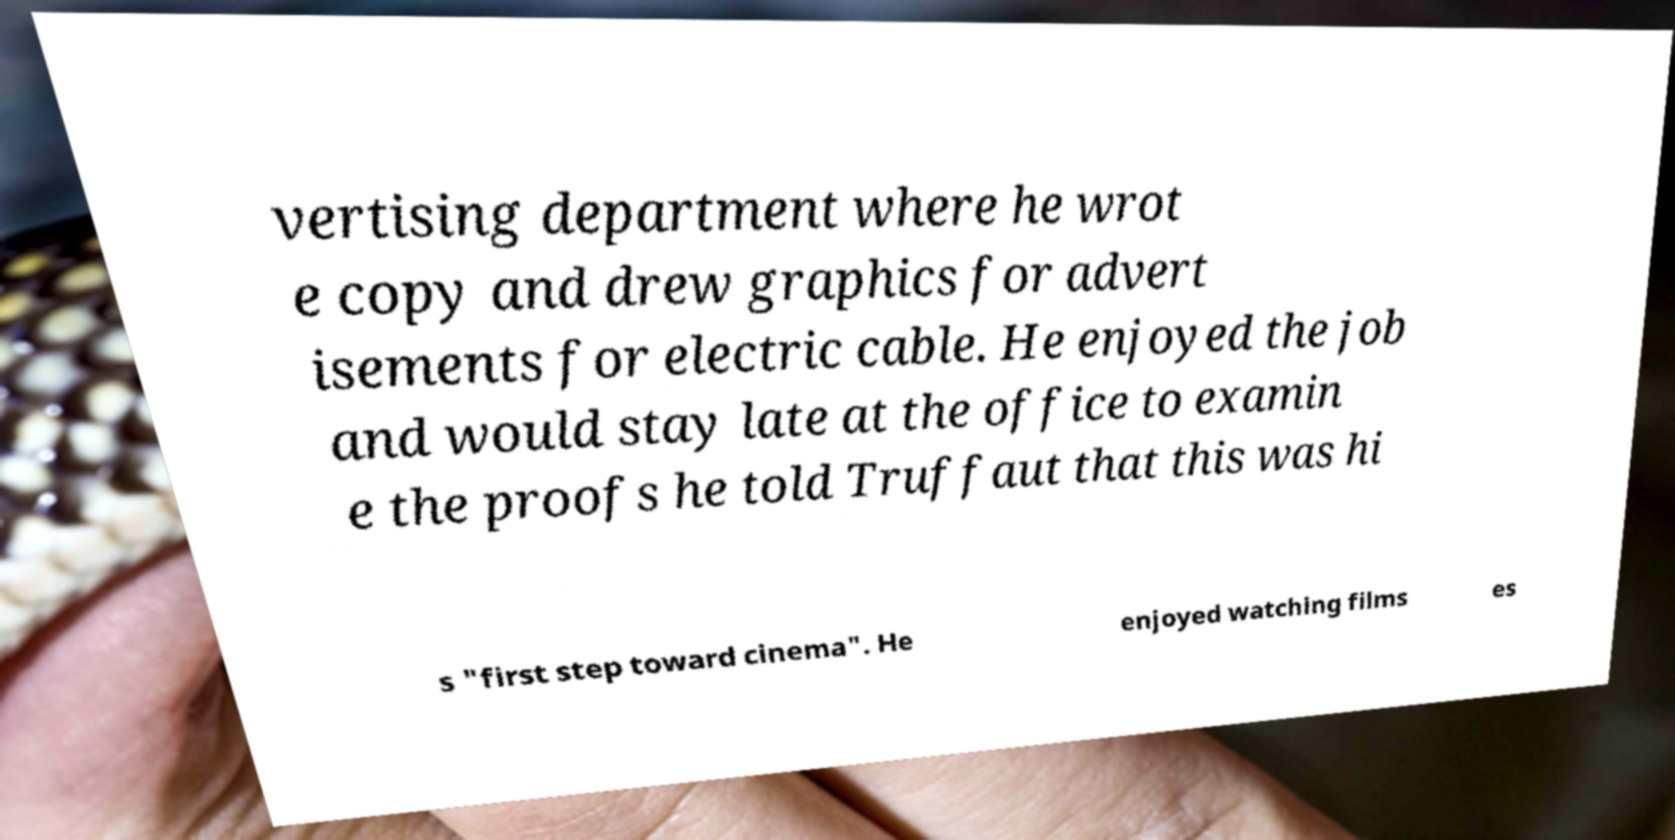Can you accurately transcribe the text from the provided image for me? vertising department where he wrot e copy and drew graphics for advert isements for electric cable. He enjoyed the job and would stay late at the office to examin e the proofs he told Truffaut that this was hi s "first step toward cinema". He enjoyed watching films es 